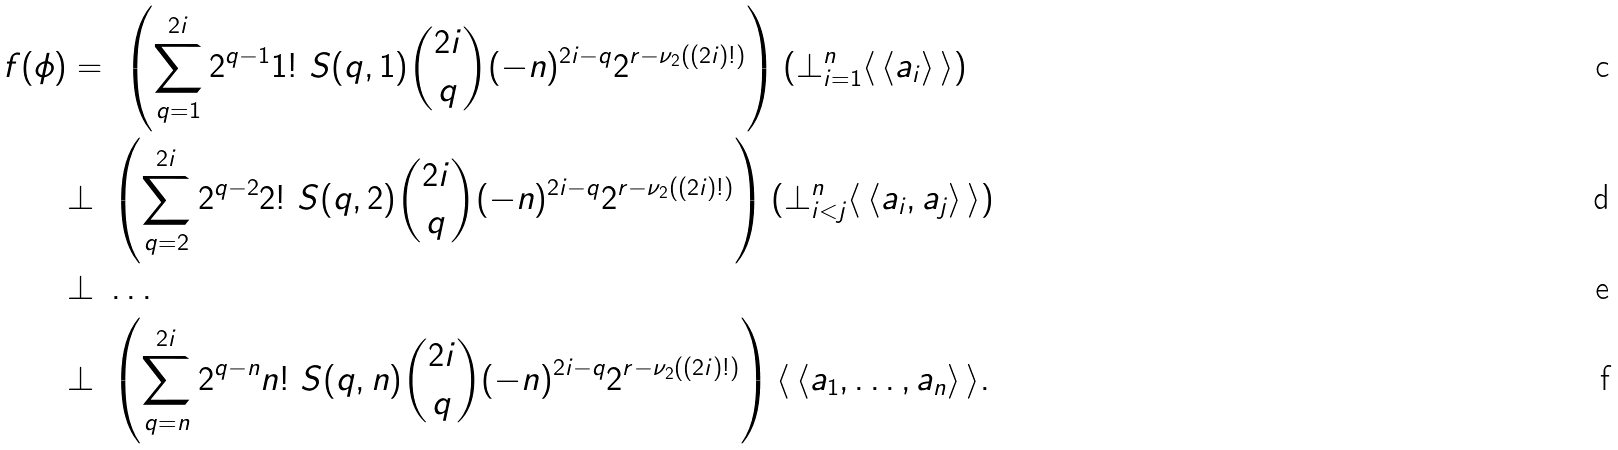Convert formula to latex. <formula><loc_0><loc_0><loc_500><loc_500>f ( \phi ) & = \ \left ( \sum _ { q = 1 } ^ { 2 i } 2 ^ { q - 1 } 1 ! \ S ( q , 1 ) { 2 i \choose q } ( - n ) ^ { 2 i - q } 2 ^ { r - \nu _ { 2 } ( ( 2 i ) ! ) } \right ) ( \bot _ { i = 1 } ^ { n } \langle \, \langle a _ { i } \rangle \, \rangle ) \\ & \bot \ \left ( \sum _ { q = 2 } ^ { 2 i } 2 ^ { q - 2 } 2 ! \ S ( q , 2 ) { 2 i \choose q } ( - n ) ^ { 2 i - q } 2 ^ { r - \nu _ { 2 } ( ( 2 i ) ! ) } \right ) ( \bot _ { i < j } ^ { n } \langle \, \langle a _ { i } , a _ { j } \rangle \, \rangle ) \\ & \bot \ \dots \\ & \bot \ \left ( \sum _ { q = n } ^ { 2 i } 2 ^ { q - n } n ! \ S ( q , n ) { 2 i \choose q } ( - n ) ^ { 2 i - q } 2 ^ { r - \nu _ { 2 } ( ( 2 i ) ! ) } \right ) \langle \, \langle a _ { 1 } , \dots , a _ { n } \rangle \, \rangle .</formula> 